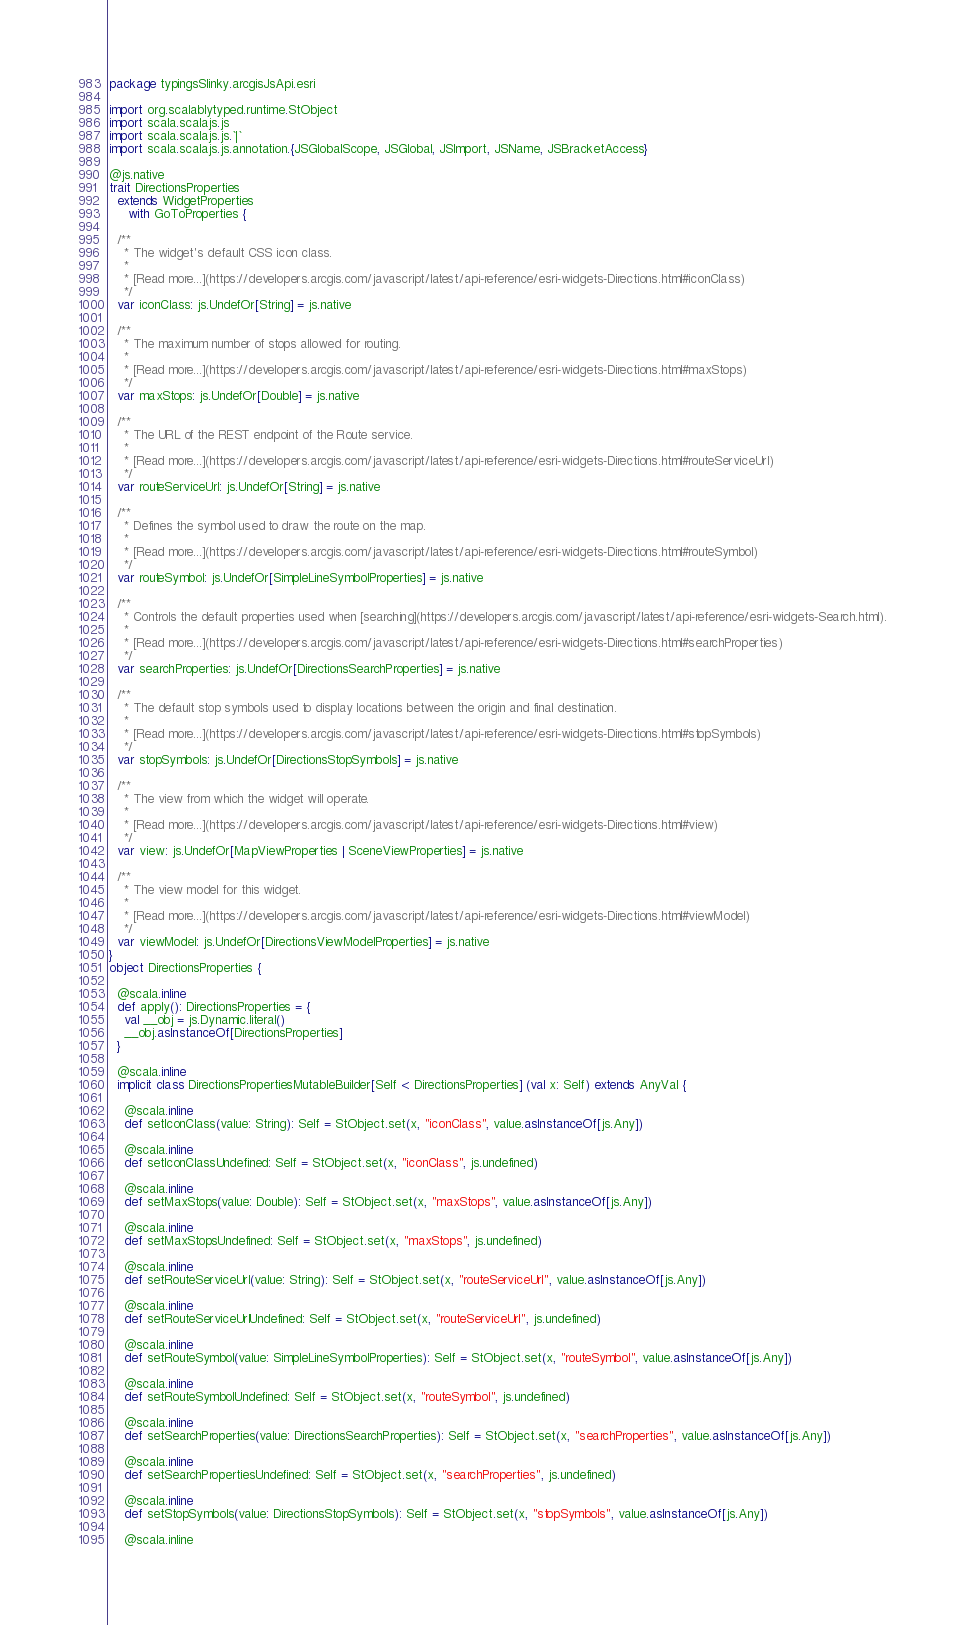<code> <loc_0><loc_0><loc_500><loc_500><_Scala_>package typingsSlinky.arcgisJsApi.esri

import org.scalablytyped.runtime.StObject
import scala.scalajs.js
import scala.scalajs.js.`|`
import scala.scalajs.js.annotation.{JSGlobalScope, JSGlobal, JSImport, JSName, JSBracketAccess}

@js.native
trait DirectionsProperties
  extends WidgetProperties
     with GoToProperties {
  
  /**
    * The widget's default CSS icon class.
    *
    * [Read more...](https://developers.arcgis.com/javascript/latest/api-reference/esri-widgets-Directions.html#iconClass)
    */
  var iconClass: js.UndefOr[String] = js.native
  
  /**
    * The maximum number of stops allowed for routing.
    *
    * [Read more...](https://developers.arcgis.com/javascript/latest/api-reference/esri-widgets-Directions.html#maxStops)
    */
  var maxStops: js.UndefOr[Double] = js.native
  
  /**
    * The URL of the REST endpoint of the Route service.
    *
    * [Read more...](https://developers.arcgis.com/javascript/latest/api-reference/esri-widgets-Directions.html#routeServiceUrl)
    */
  var routeServiceUrl: js.UndefOr[String] = js.native
  
  /**
    * Defines the symbol used to draw the route on the map.
    *
    * [Read more...](https://developers.arcgis.com/javascript/latest/api-reference/esri-widgets-Directions.html#routeSymbol)
    */
  var routeSymbol: js.UndefOr[SimpleLineSymbolProperties] = js.native
  
  /**
    * Controls the default properties used when [searching](https://developers.arcgis.com/javascript/latest/api-reference/esri-widgets-Search.html).
    *
    * [Read more...](https://developers.arcgis.com/javascript/latest/api-reference/esri-widgets-Directions.html#searchProperties)
    */
  var searchProperties: js.UndefOr[DirectionsSearchProperties] = js.native
  
  /**
    * The default stop symbols used to display locations between the origin and final destination.
    *
    * [Read more...](https://developers.arcgis.com/javascript/latest/api-reference/esri-widgets-Directions.html#stopSymbols)
    */
  var stopSymbols: js.UndefOr[DirectionsStopSymbols] = js.native
  
  /**
    * The view from which the widget will operate.
    *
    * [Read more...](https://developers.arcgis.com/javascript/latest/api-reference/esri-widgets-Directions.html#view)
    */
  var view: js.UndefOr[MapViewProperties | SceneViewProperties] = js.native
  
  /**
    * The view model for this widget.
    *
    * [Read more...](https://developers.arcgis.com/javascript/latest/api-reference/esri-widgets-Directions.html#viewModel)
    */
  var viewModel: js.UndefOr[DirectionsViewModelProperties] = js.native
}
object DirectionsProperties {
  
  @scala.inline
  def apply(): DirectionsProperties = {
    val __obj = js.Dynamic.literal()
    __obj.asInstanceOf[DirectionsProperties]
  }
  
  @scala.inline
  implicit class DirectionsPropertiesMutableBuilder[Self <: DirectionsProperties] (val x: Self) extends AnyVal {
    
    @scala.inline
    def setIconClass(value: String): Self = StObject.set(x, "iconClass", value.asInstanceOf[js.Any])
    
    @scala.inline
    def setIconClassUndefined: Self = StObject.set(x, "iconClass", js.undefined)
    
    @scala.inline
    def setMaxStops(value: Double): Self = StObject.set(x, "maxStops", value.asInstanceOf[js.Any])
    
    @scala.inline
    def setMaxStopsUndefined: Self = StObject.set(x, "maxStops", js.undefined)
    
    @scala.inline
    def setRouteServiceUrl(value: String): Self = StObject.set(x, "routeServiceUrl", value.asInstanceOf[js.Any])
    
    @scala.inline
    def setRouteServiceUrlUndefined: Self = StObject.set(x, "routeServiceUrl", js.undefined)
    
    @scala.inline
    def setRouteSymbol(value: SimpleLineSymbolProperties): Self = StObject.set(x, "routeSymbol", value.asInstanceOf[js.Any])
    
    @scala.inline
    def setRouteSymbolUndefined: Self = StObject.set(x, "routeSymbol", js.undefined)
    
    @scala.inline
    def setSearchProperties(value: DirectionsSearchProperties): Self = StObject.set(x, "searchProperties", value.asInstanceOf[js.Any])
    
    @scala.inline
    def setSearchPropertiesUndefined: Self = StObject.set(x, "searchProperties", js.undefined)
    
    @scala.inline
    def setStopSymbols(value: DirectionsStopSymbols): Self = StObject.set(x, "stopSymbols", value.asInstanceOf[js.Any])
    
    @scala.inline</code> 